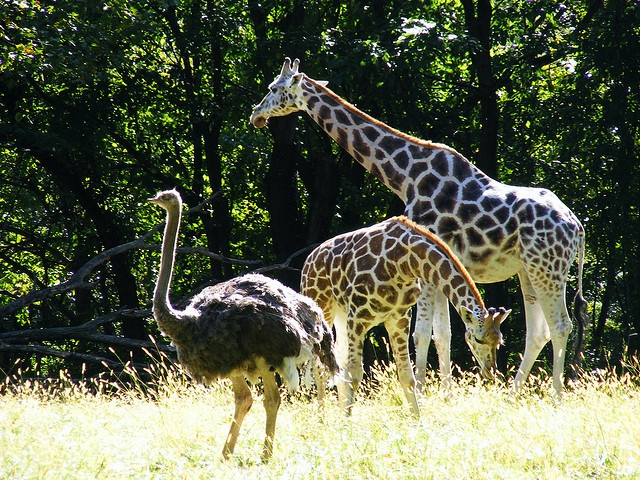Describe the objects in this image and their specific colors. I can see giraffe in green, black, darkgray, olive, and gray tones, giraffe in green, tan, darkgray, black, and maroon tones, and bird in green, black, white, olive, and gray tones in this image. 